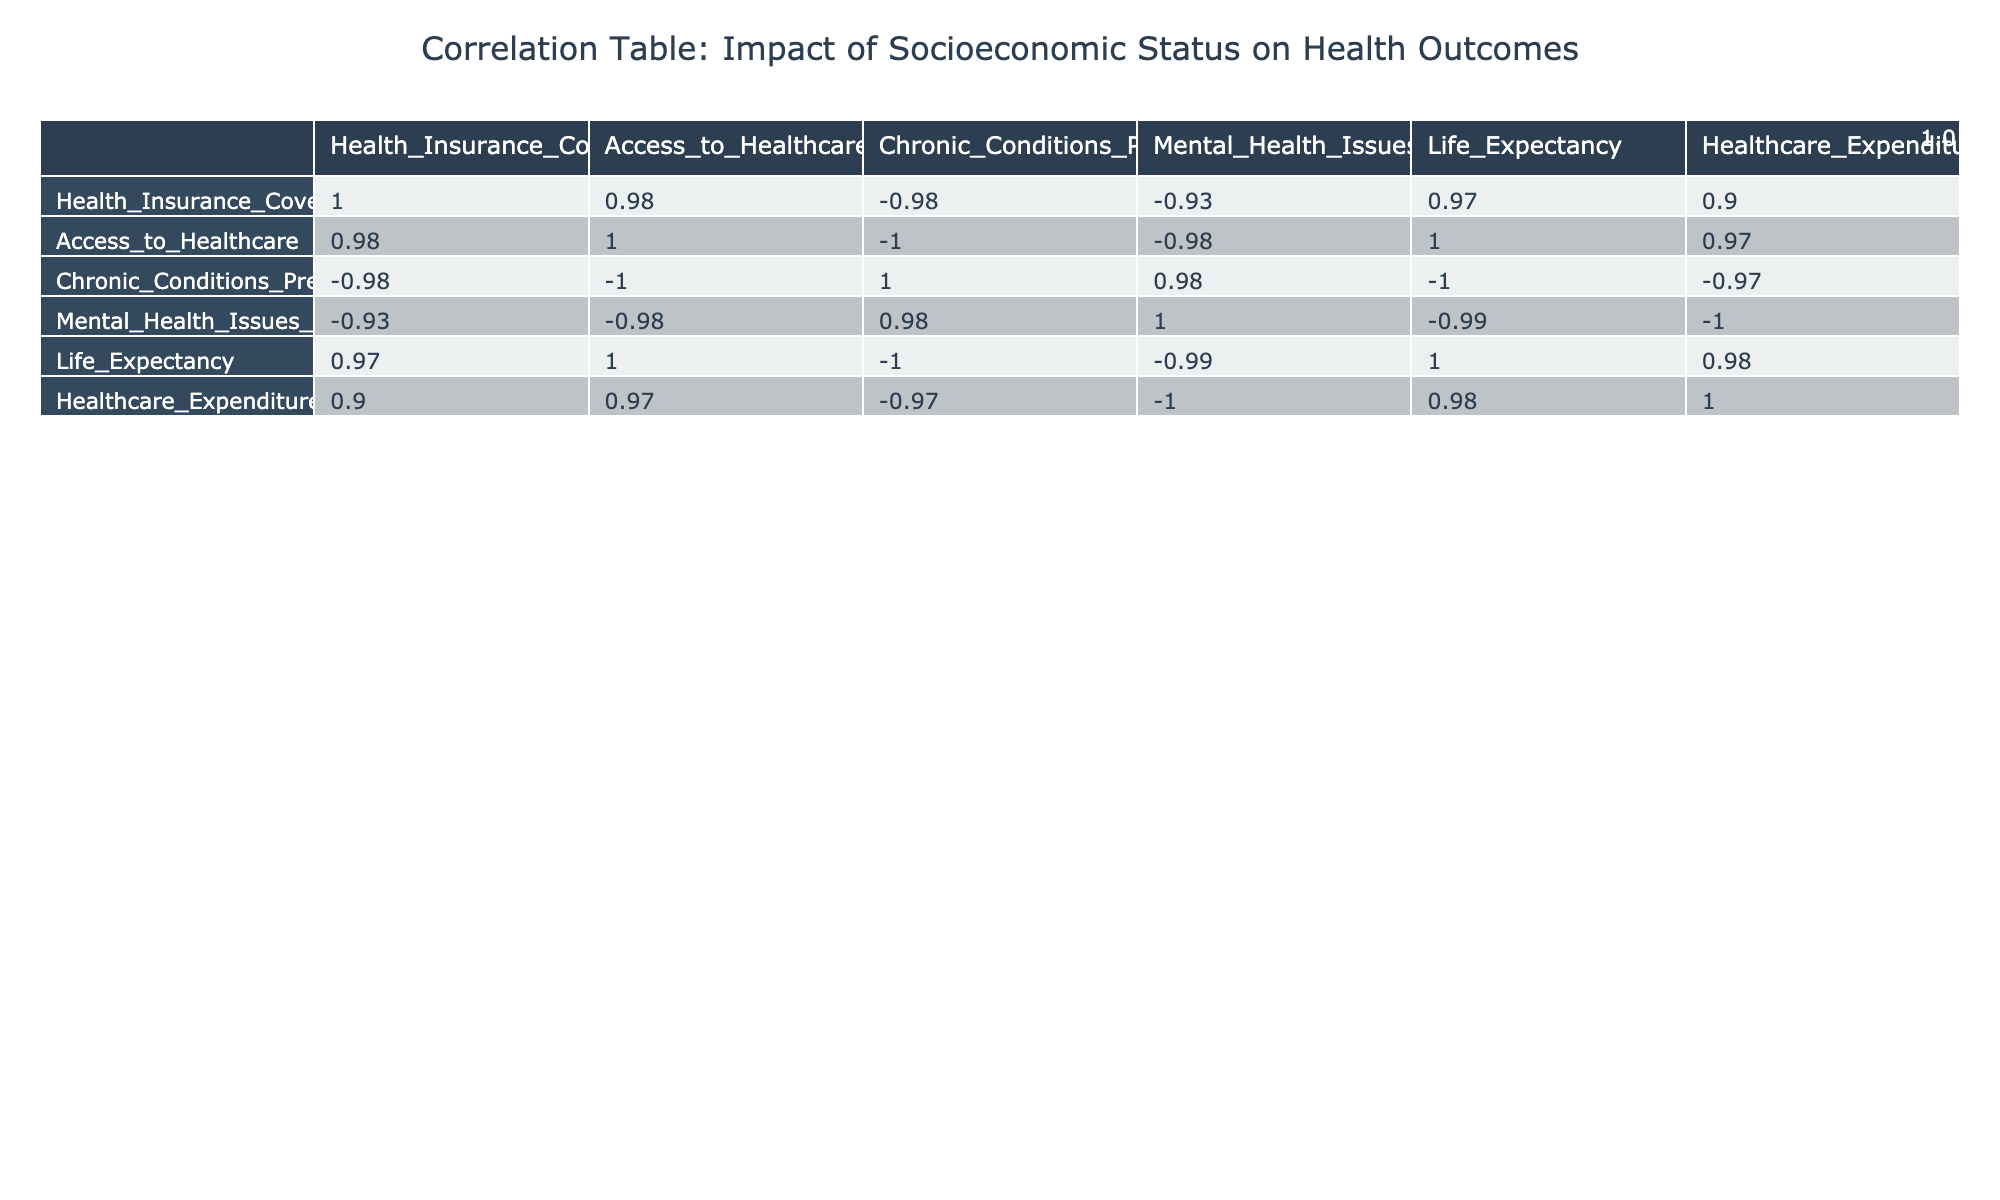What is the correlation between socioeconomic status and life expectancy? The correlation coefficient between socioeconomic status and life expectancy is 0.99, which indicates a very strong positive relationship. As socioeconomic status increases, life expectancy tends to increase as well.
Answer: 0.99 Which socioeconomic status group has the highest healthcare expenditure per capita? The high socioeconomic status group has the highest healthcare expenditure per capita of 11,000. This is directly taken from the table where the values for healthcare expenditure are provided for each socioeconomic group.
Answer: 11,000 Is there a negative correlation between socioeconomic status and chronic conditions prevalence? Yes, the correlation coefficient shows a negative value (-0.98) between socioeconomic status and chronic conditions prevalence, indicating that as socioeconomic status increases, the prevalence of chronic conditions decreases.
Answer: Yes What is the average percentage of health insurance coverage for the middle and upper-middle socioeconomic status groups? The health insurance coverage for the middle group is 85 and for the upper-middle group is 90. To find the average, calculate (85 + 90) / 2 = 87.5.
Answer: 87.5 Which socioeconomic status group has the lowest prevalence of mental health issues? The high socioeconomic status group has the lowest prevalence of mental health issues at 15. This can be derived from the mental health issues prevalence values listed opposite each socioeconomic status in the table.
Answer: 15 What is the difference in life expectancy between the low and high socioeconomic status groups? The life expectancy for the low group is 74 and for the high group is 85. The difference is calculated as 85 - 74 = 11 years.
Answer: 11 Is the access to healthcare greater in the low-middle socioeconomic group compared to the low group? Yes, the low-middle group has an access to healthcare value of 3, while the low group has a value of 2, indicating that access is greater in the low-middle group.
Answer: Yes What is the sum of healthcare expenditures for low, low-middle, and middle socioeconomic status groups? The healthcare expenditures for these groups are 4,800 (low) + 5,200 (low-middle) + 6,600 (middle). The sum is calculated as 4,800 + 5,200 + 6,600 = 16,600.
Answer: 16,600 What does the correlation of 0.95 between socioeconomic status and health insurance coverage indicate? A correlation of 0.95 indicates a very strong positive relationship; as socioeconomic status improves, health insurance coverage also significantly increases.
Answer: 0.95 